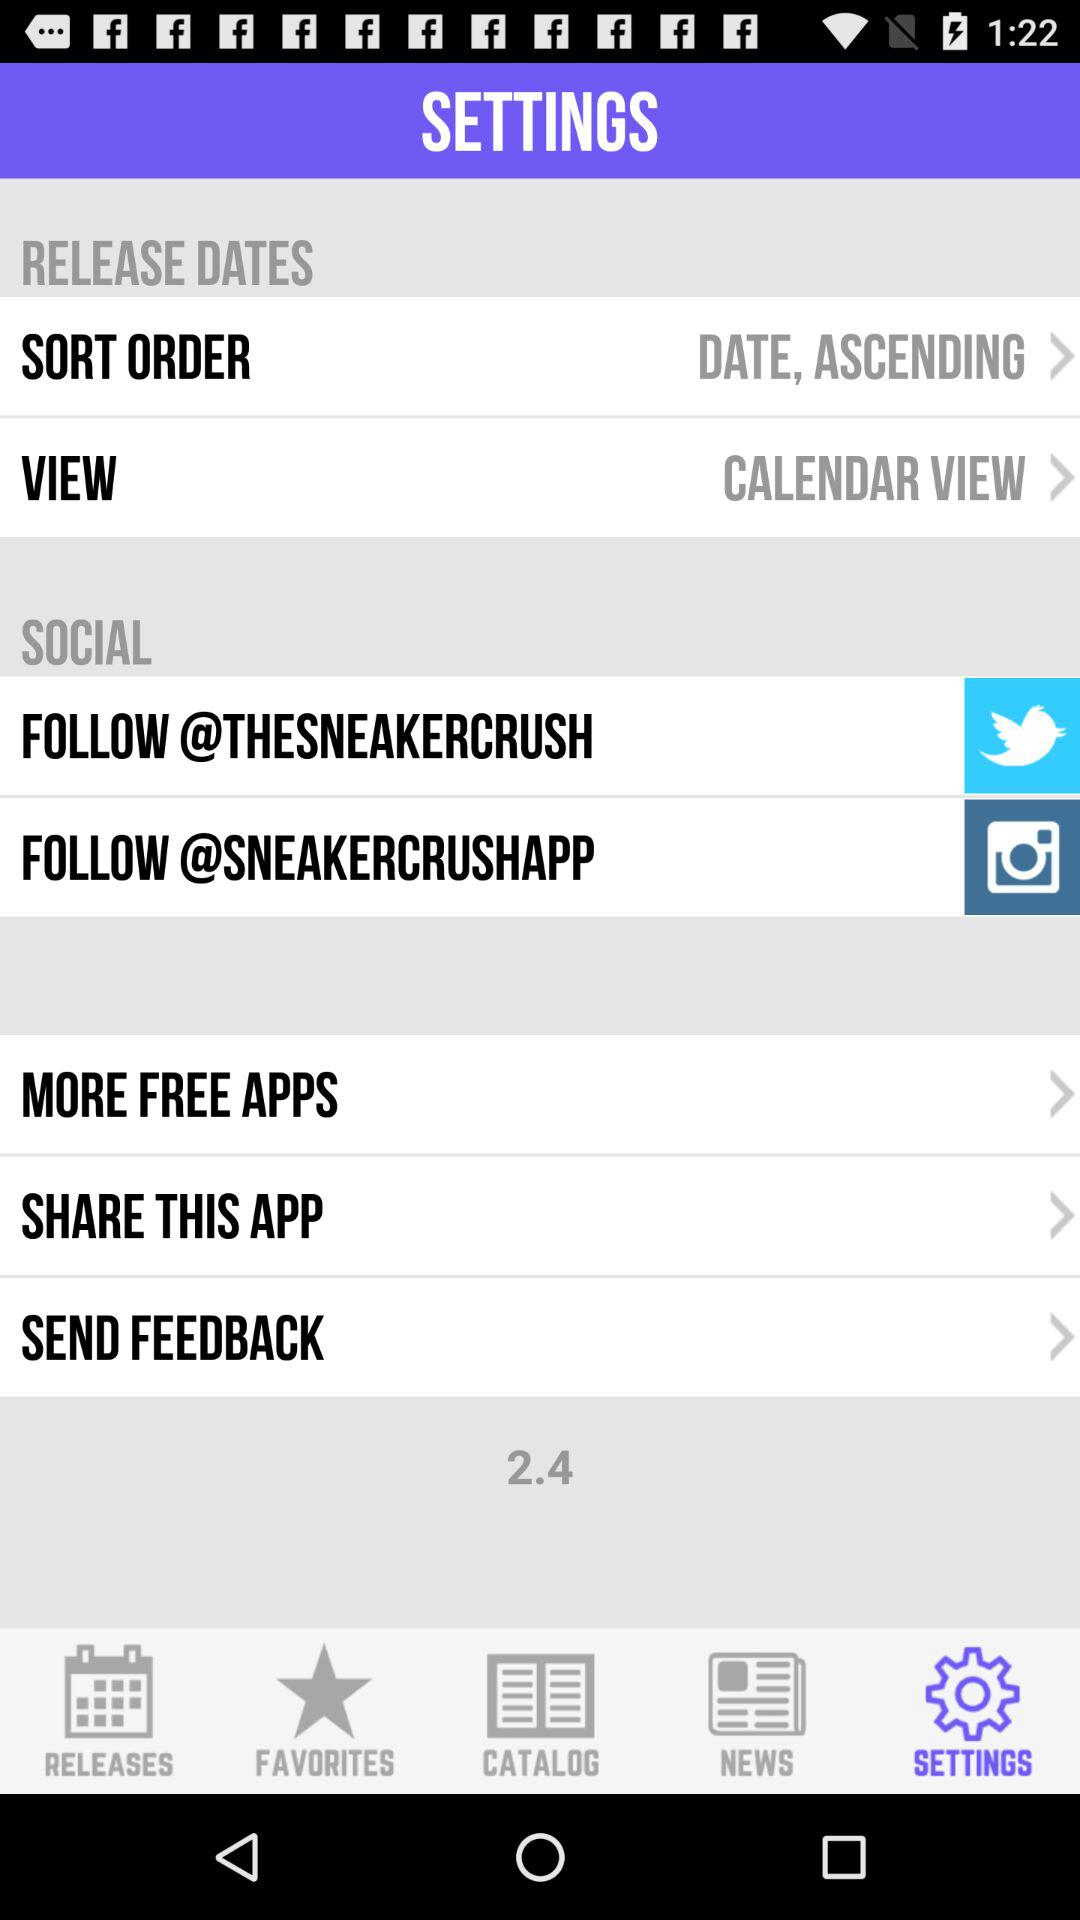What is the selected view? The selected view is "CALENDAR VIEW". 